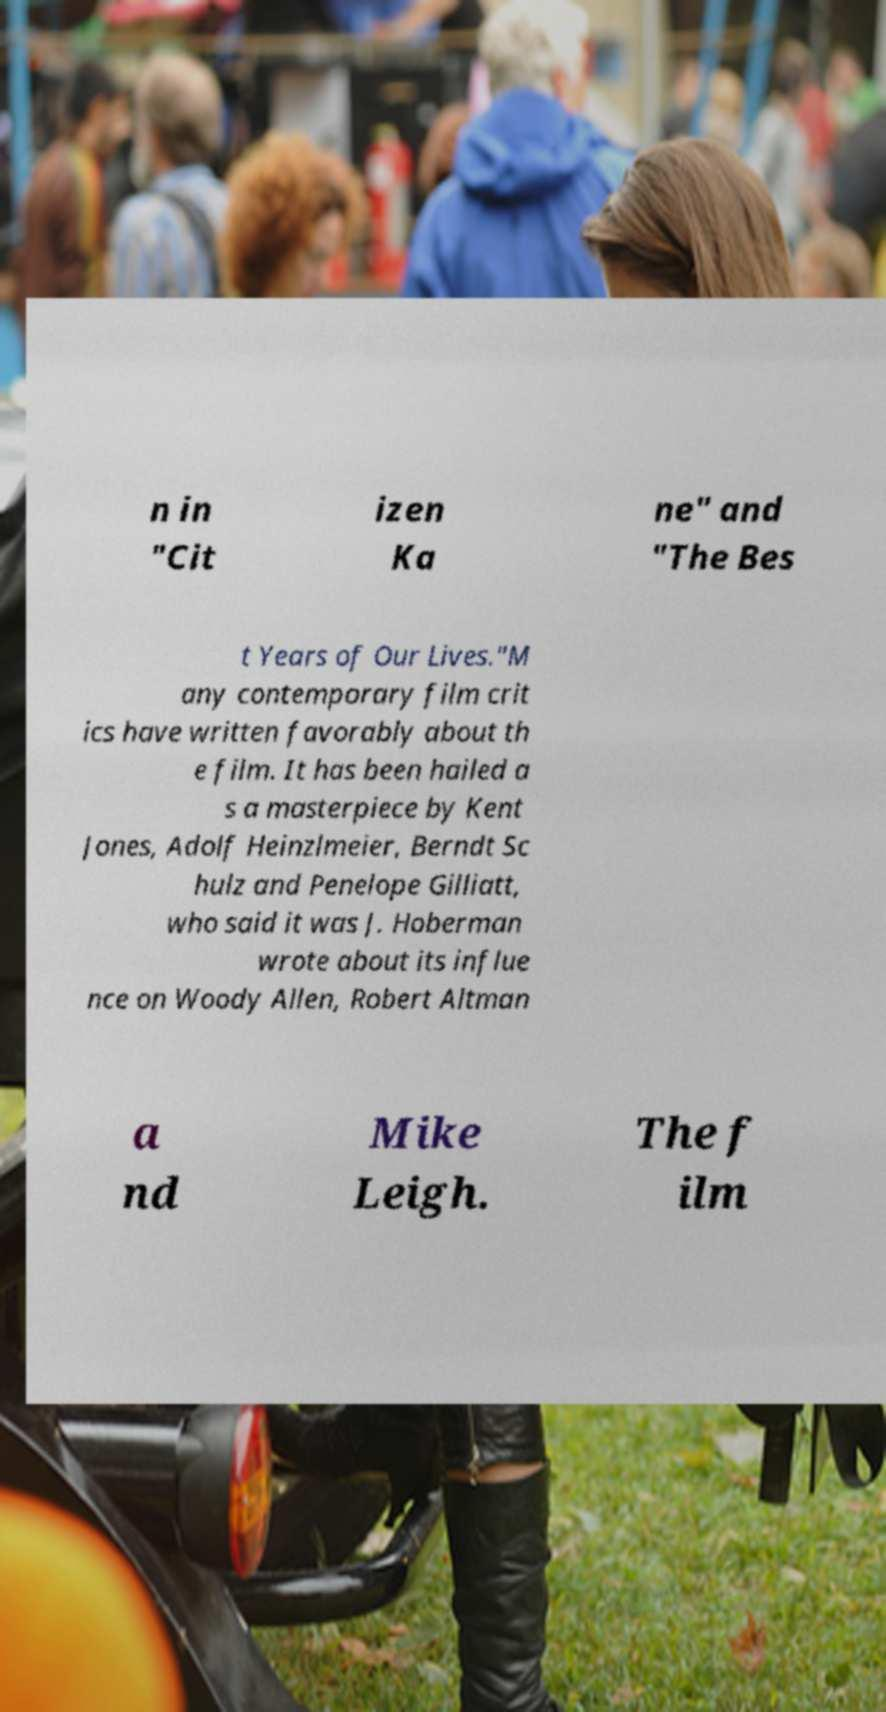Please identify and transcribe the text found in this image. n in "Cit izen Ka ne" and "The Bes t Years of Our Lives."M any contemporary film crit ics have written favorably about th e film. It has been hailed a s a masterpiece by Kent Jones, Adolf Heinzlmeier, Berndt Sc hulz and Penelope Gilliatt, who said it was J. Hoberman wrote about its influe nce on Woody Allen, Robert Altman a nd Mike Leigh. The f ilm 